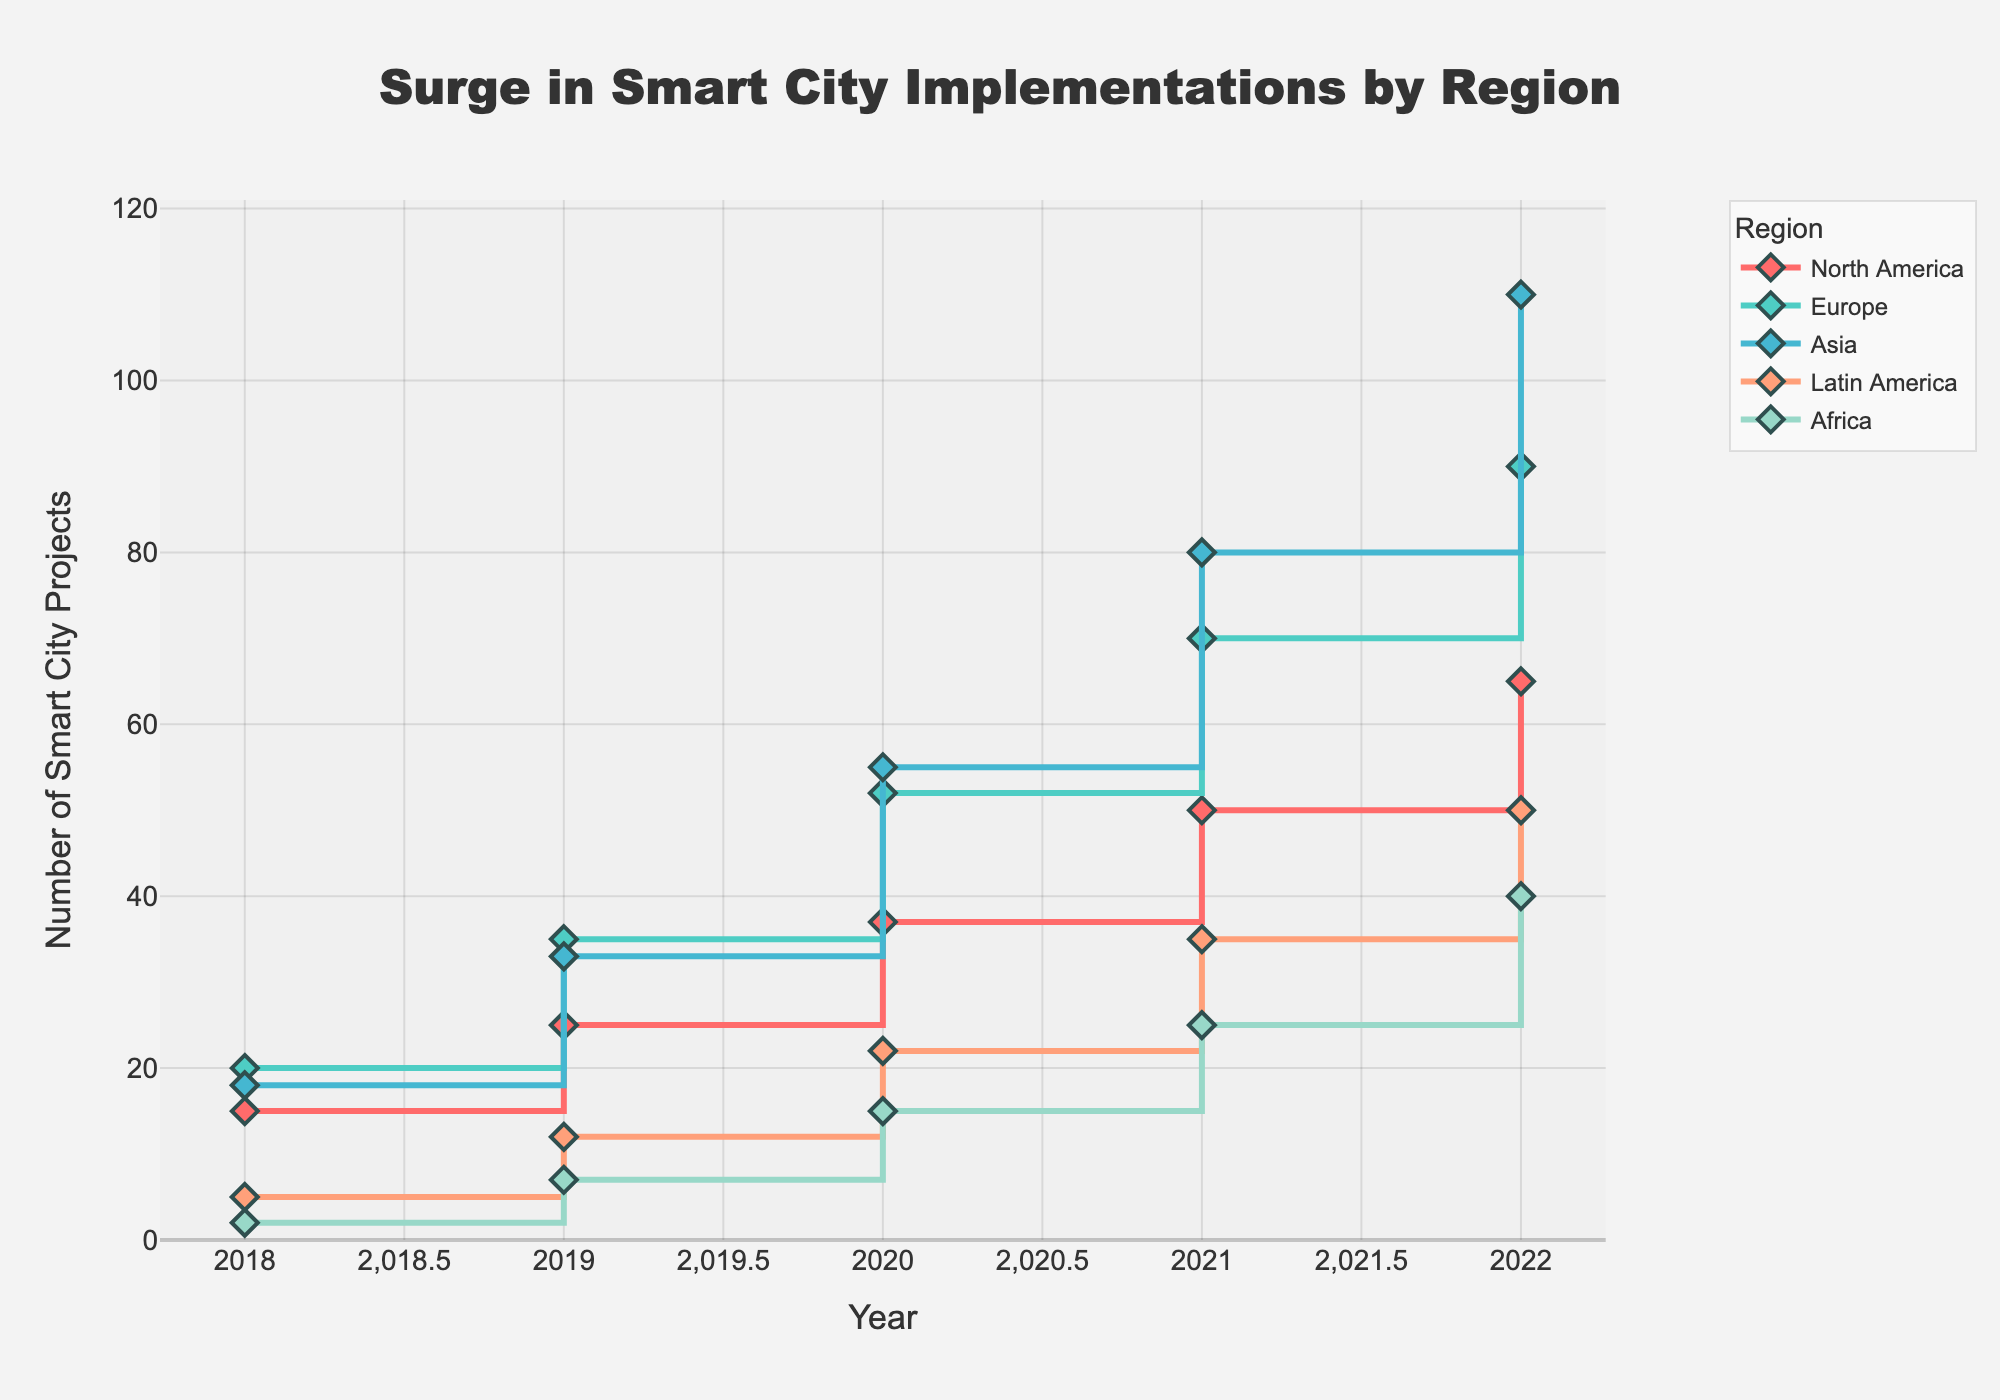What is the title of the plot? The title of the plot is displayed at the top center of the figure, typically in bold and larger font size. It summarizes the overall content of the plot, indicating what the viewer should focus on.
Answer: Surge in Smart City Implementations by Region How many regions are represented in the plot? The legend at the right side of the plot lists the regions, each associated with a unique color. By counting these entries, the number of represented regions can be determined.
Answer: 5 In which year did Asia have the highest number of smart city projects? The Asia data line can be traced across the years. The data point with the highest value will represent the year with the highest number. The line color identified from the legend helps to find Asia's specific data on the plot.
Answer: 2022 Which region had the least number of smart city projects in 2020? By examining the Y-axis values corresponding to 2020 for each region's line, the trend line that reaches the lowest point on the Y-axis determines the region with the least projects that year.
Answer: Africa How many smart city projects were there in North America in 2022? Locate the North America line by its designated color in the legend. Then follow it to the year 2022 on the X-axis to find the corresponding data point on the Y-axis.
Answer: 65 What is the average increase in the number of smart city projects per year for Europe from 2018 to 2022? First, calculate the total increase from 2018 (20) to 2022 (90): 90 - 20 = 70. Then, divide this increase by the number of years (5 - 1 = 4): 70 ÷ 4 = 17.5.
Answer: 17.5 Which region saw the greatest increase in the number of smart city projects between 2018 and 2022? Calculate the increase for each region by subtracting the 2018 value from the 2022 value. Compare these increases to find the greatest one. Increases: North America (65-15=50), Europe (90-20=70), Asia (110-18=92), Latin America (50-5=45), Africa (40-2=38).
Answer: Asia Between which consecutive years did Latin America see the highest increase in smart city projects? For Latin America, calculate the year-to-year differences: 2019-2018 (12-5=7), 2020-2019 (22-12=10), 2021-2020 (35-22=13), 2022-2021 (50-35=15). The highest increase is between 2021 and 2022.
Answer: 2021 and 2022 How does the number of smart city projects in Africa in 2020 compare to those in Latin America in 2018? Locate the data points for Africa in 2020 (15) and Latin America in 2018 (5) by following their respective trend lines to the specified years.
Answer: Africa's projects in 2020 are more than Latin America's in 2018 by 10 